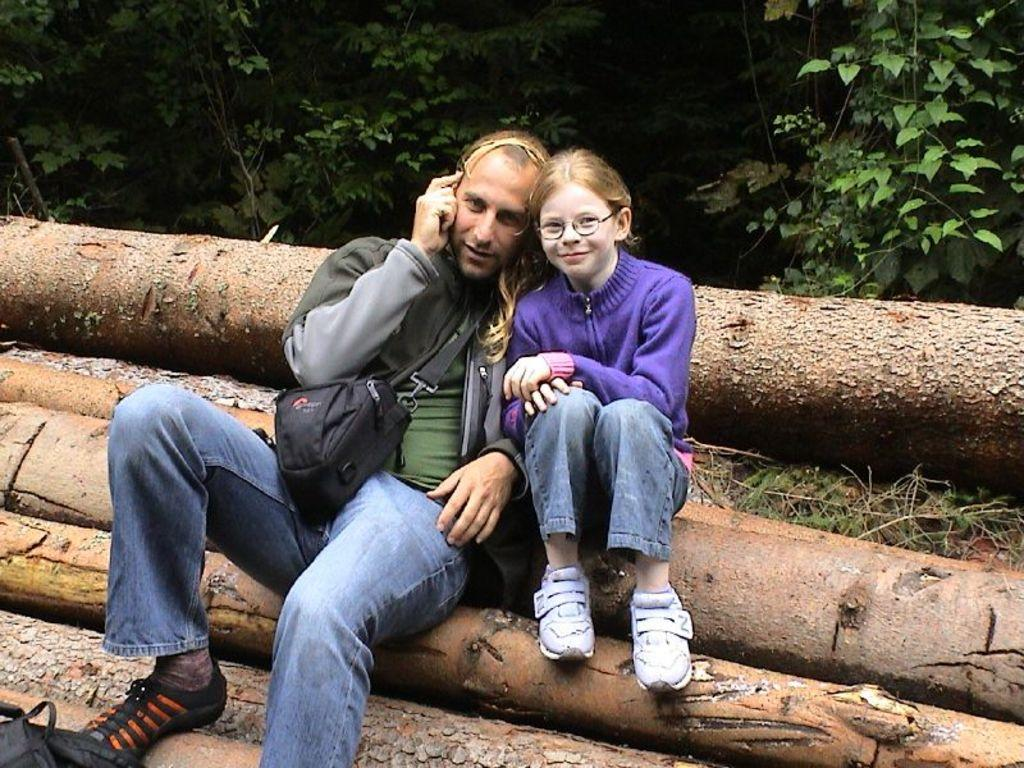Who is present in the image? There is a man and a girl in the image. What are they wearing? Both the man and the girl are wearing clothes and shoes. Where are they sitting? They are sitting on a wooden log. What can be observed about the girl's appearance? The girl is wearing spectacles. What type of natural environment is visible in the image? There is grass and a plant in the image. What type of card is the man holding in the image? There is no card present in the image. Does the man have a son in the image? The provided facts do not mention a son, so it cannot be determined from the image. 